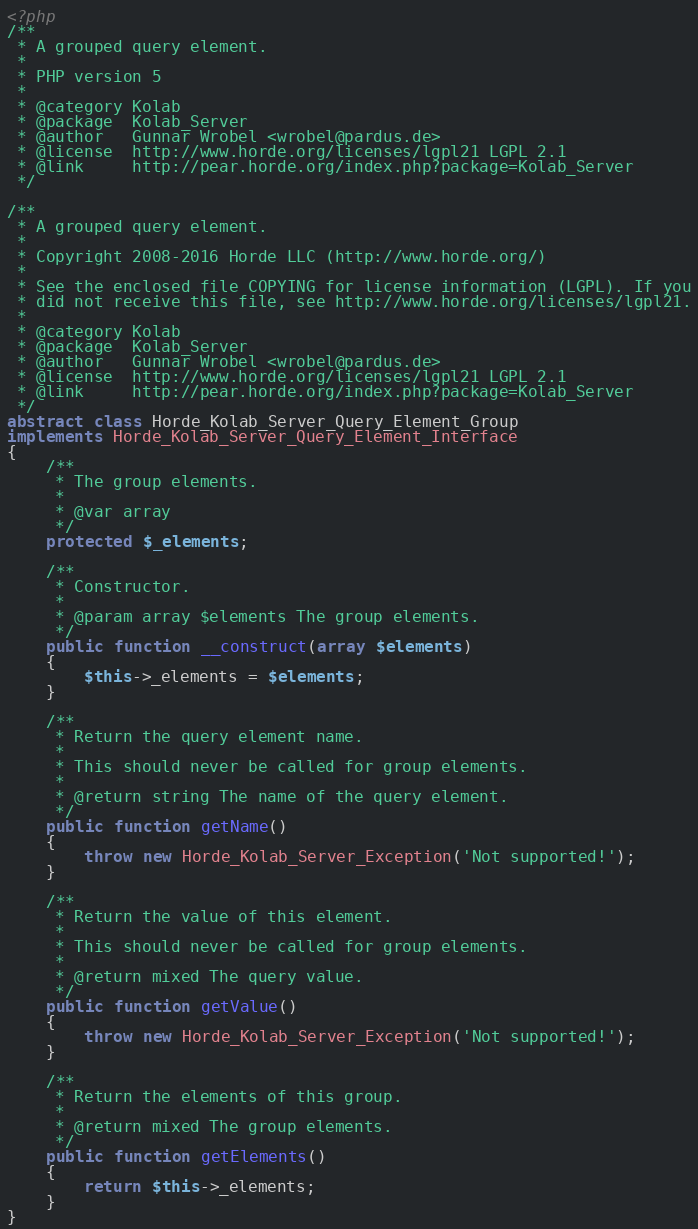Convert code to text. <code><loc_0><loc_0><loc_500><loc_500><_PHP_><?php
/**
 * A grouped query element.
 *
 * PHP version 5
 *
 * @category Kolab
 * @package  Kolab_Server
 * @author   Gunnar Wrobel <wrobel@pardus.de>
 * @license  http://www.horde.org/licenses/lgpl21 LGPL 2.1
 * @link     http://pear.horde.org/index.php?package=Kolab_Server
 */

/**
 * A grouped query element.
 *
 * Copyright 2008-2016 Horde LLC (http://www.horde.org/)
 *
 * See the enclosed file COPYING for license information (LGPL). If you
 * did not receive this file, see http://www.horde.org/licenses/lgpl21.
 *
 * @category Kolab
 * @package  Kolab_Server
 * @author   Gunnar Wrobel <wrobel@pardus.de>
 * @license  http://www.horde.org/licenses/lgpl21 LGPL 2.1
 * @link     http://pear.horde.org/index.php?package=Kolab_Server
 */
abstract class Horde_Kolab_Server_Query_Element_Group
implements Horde_Kolab_Server_Query_Element_Interface
{
    /**
     * The group elements.
     *
     * @var array
     */
    protected $_elements;

    /**
     * Constructor.
     *
     * @param array $elements The group elements.
     */
    public function __construct(array $elements)
    {
        $this->_elements = $elements;
    }

    /**
     * Return the query element name.
     *
     * This should never be called for group elements.
     *
     * @return string The name of the query element.
     */
    public function getName()
    {
        throw new Horde_Kolab_Server_Exception('Not supported!');
    }

    /**
     * Return the value of this element.
     *
     * This should never be called for group elements.
     *
     * @return mixed The query value.
     */
    public function getValue()
    {
        throw new Horde_Kolab_Server_Exception('Not supported!');
    }

    /**
     * Return the elements of this group.
     *
     * @return mixed The group elements.
     */
    public function getElements()
    {
        return $this->_elements;
    }
}</code> 